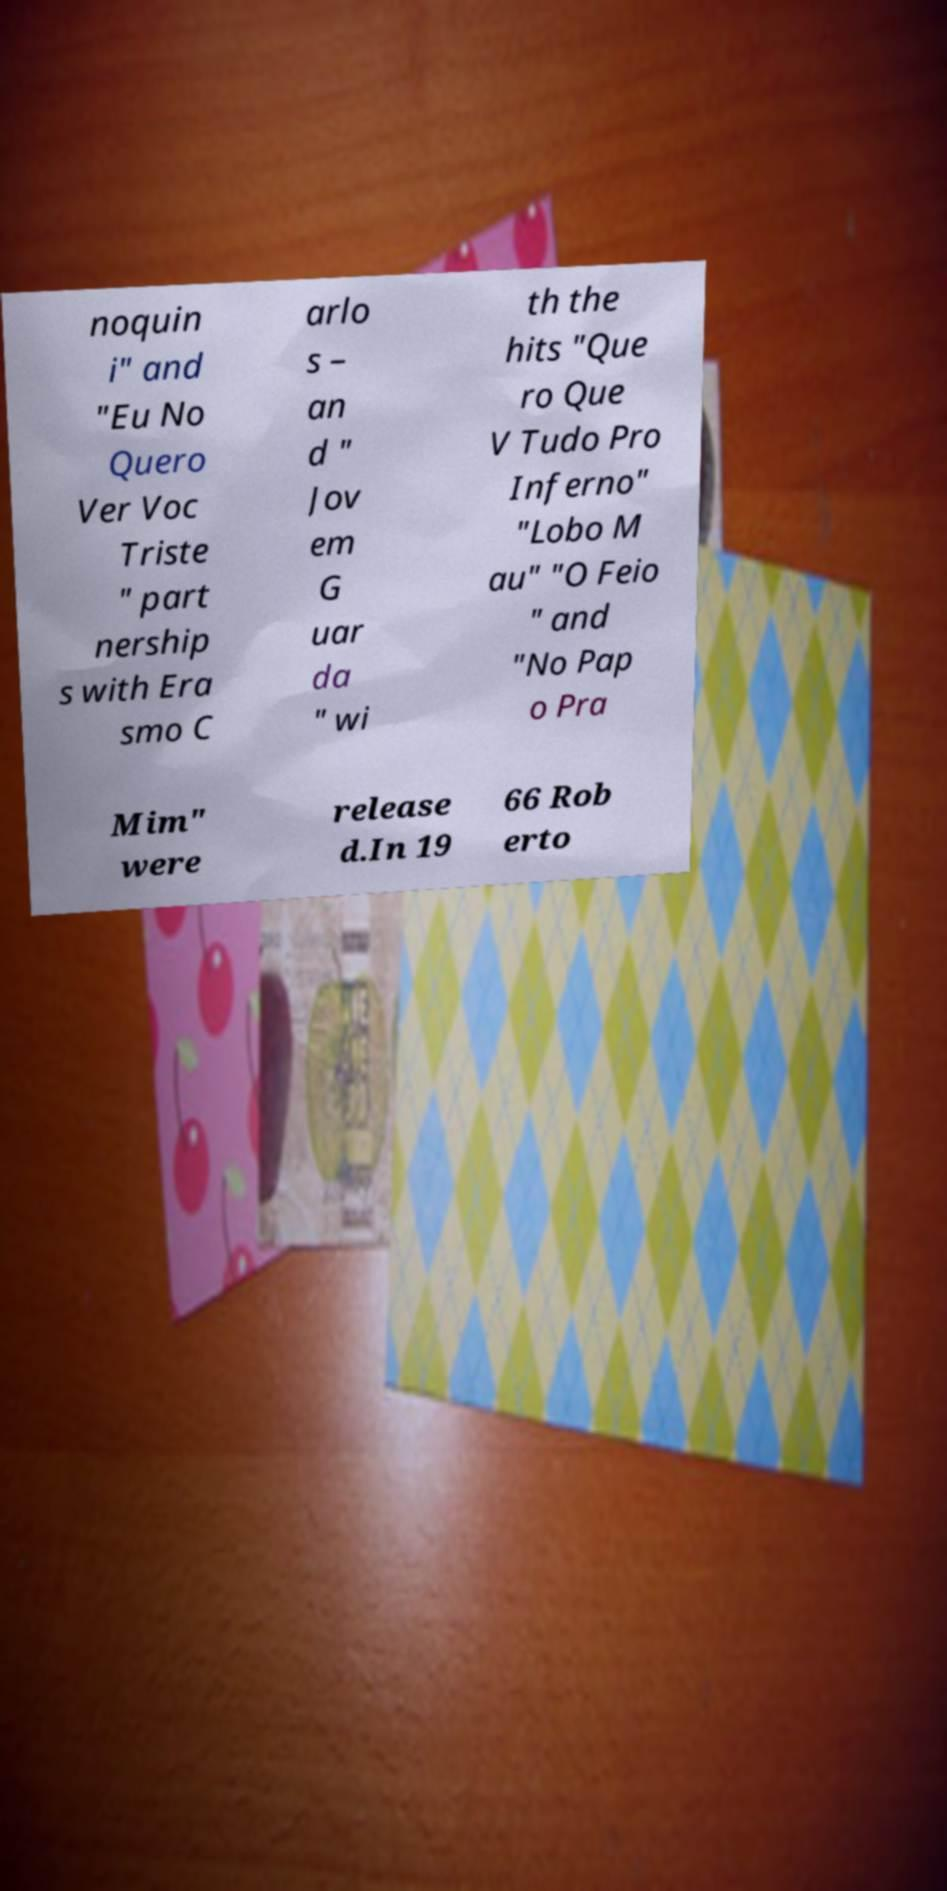Can you read and provide the text displayed in the image?This photo seems to have some interesting text. Can you extract and type it out for me? noquin i" and "Eu No Quero Ver Voc Triste " part nership s with Era smo C arlo s – an d " Jov em G uar da " wi th the hits "Que ro Que V Tudo Pro Inferno" "Lobo M au" "O Feio " and "No Pap o Pra Mim" were release d.In 19 66 Rob erto 